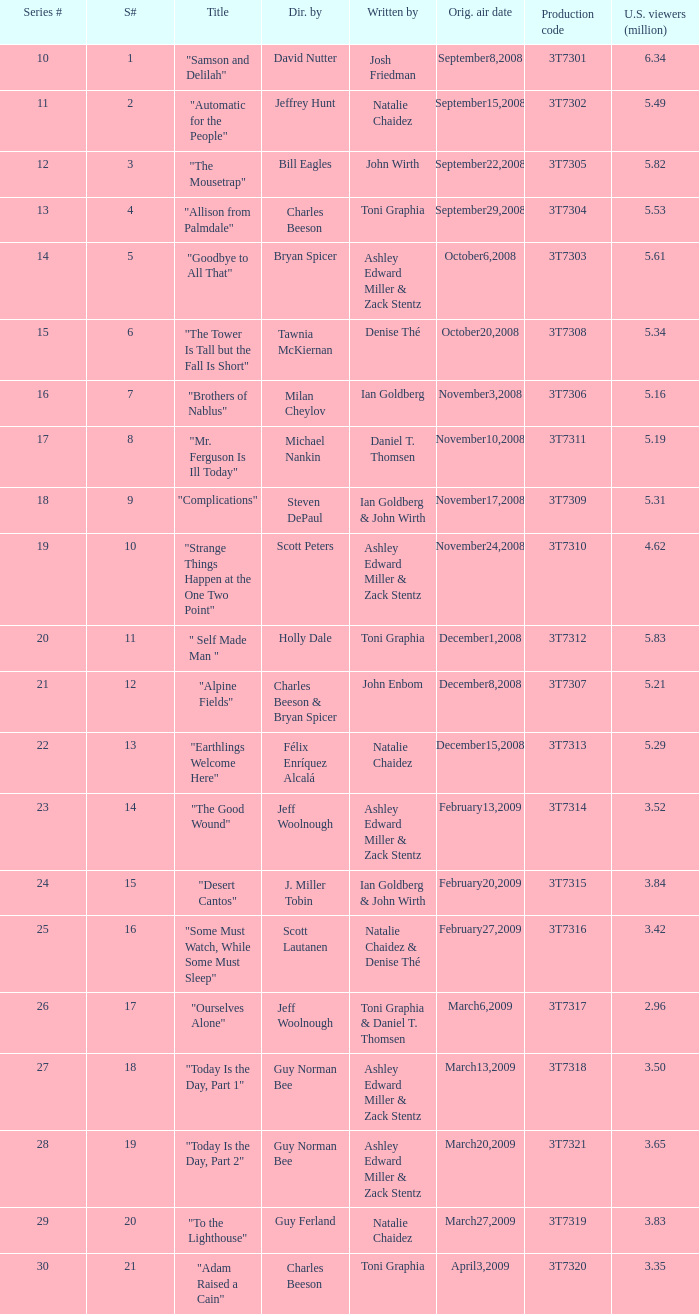How many viewers did the episode directed by David Nutter draw in? 6.34. 